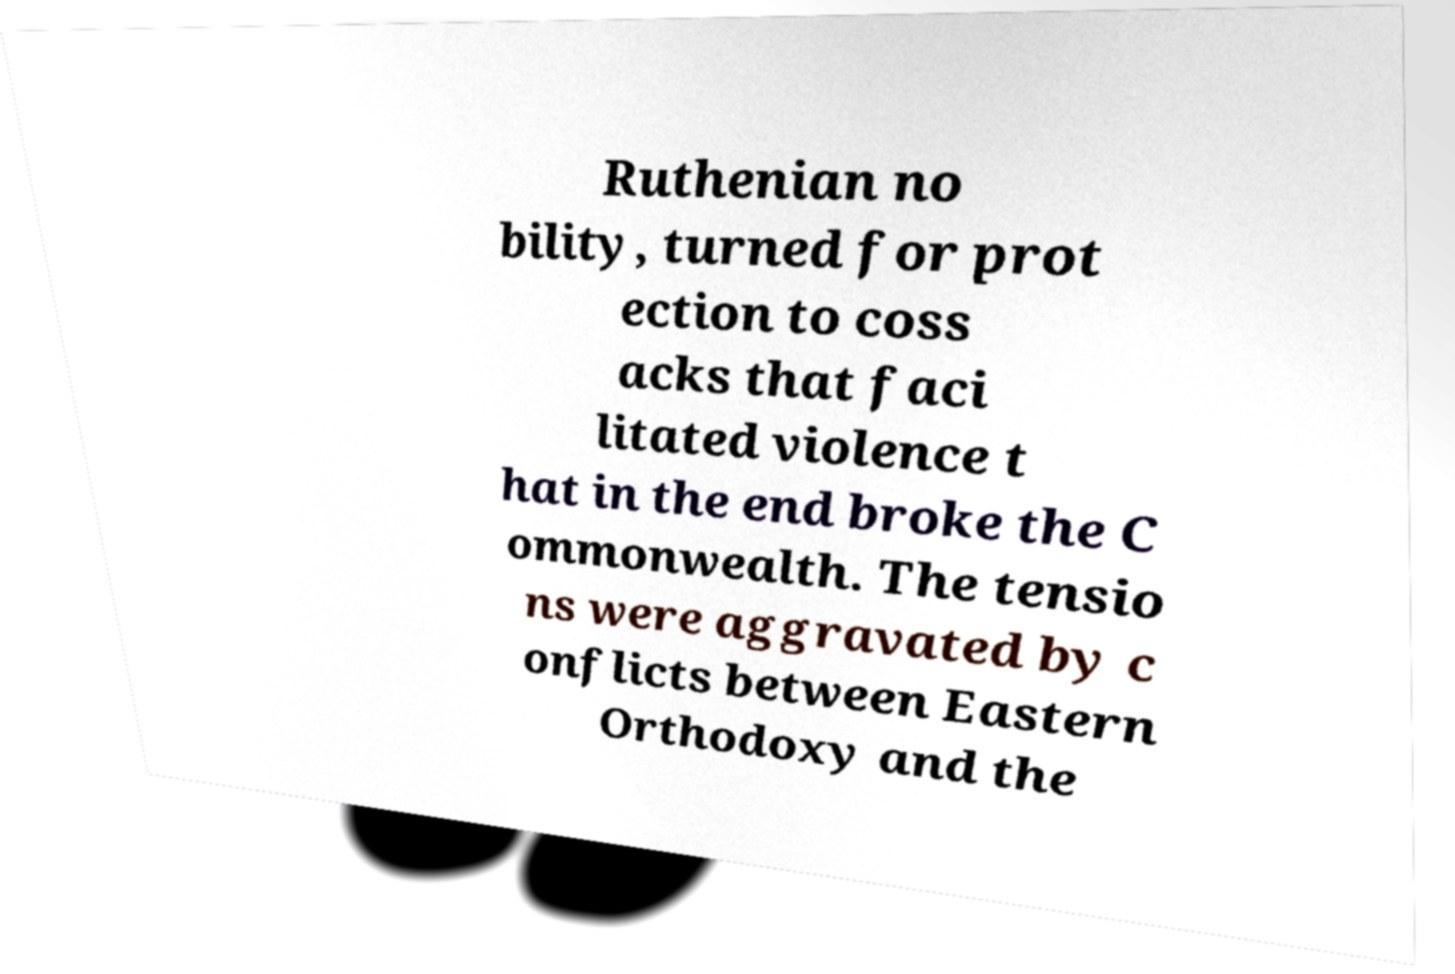There's text embedded in this image that I need extracted. Can you transcribe it verbatim? Ruthenian no bility, turned for prot ection to coss acks that faci litated violence t hat in the end broke the C ommonwealth. The tensio ns were aggravated by c onflicts between Eastern Orthodoxy and the 